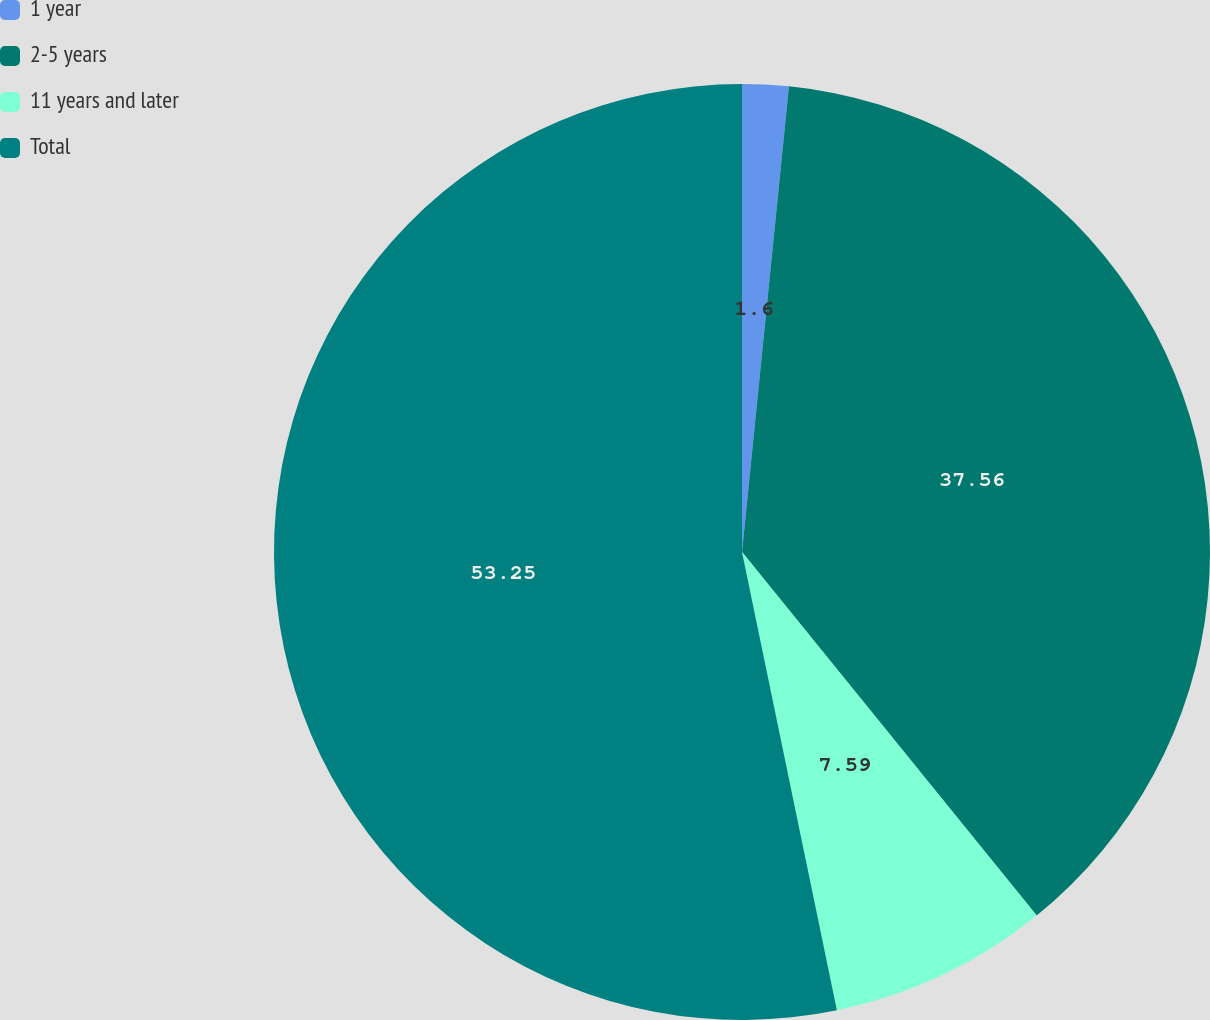Convert chart. <chart><loc_0><loc_0><loc_500><loc_500><pie_chart><fcel>1 year<fcel>2-5 years<fcel>11 years and later<fcel>Total<nl><fcel>1.6%<fcel>37.56%<fcel>7.59%<fcel>53.25%<nl></chart> 